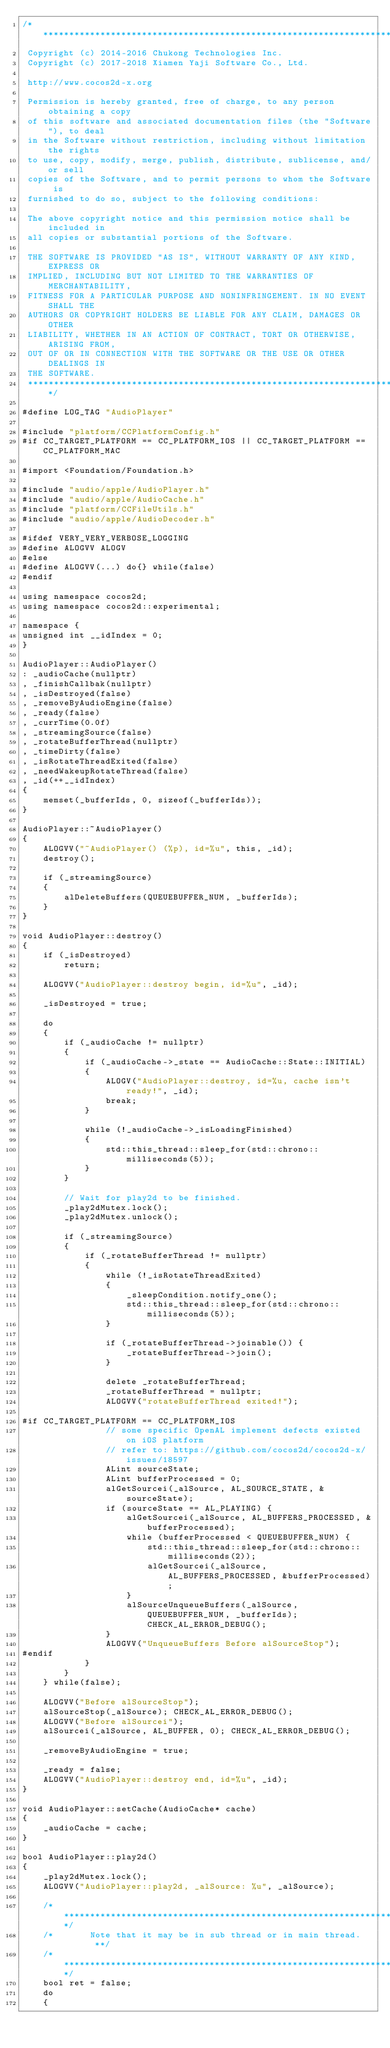<code> <loc_0><loc_0><loc_500><loc_500><_ObjectiveC_>/****************************************************************************
 Copyright (c) 2014-2016 Chukong Technologies Inc.
 Copyright (c) 2017-2018 Xiamen Yaji Software Co., Ltd.

 http://www.cocos2d-x.org

 Permission is hereby granted, free of charge, to any person obtaining a copy
 of this software and associated documentation files (the "Software"), to deal
 in the Software without restriction, including without limitation the rights
 to use, copy, modify, merge, publish, distribute, sublicense, and/or sell
 copies of the Software, and to permit persons to whom the Software is
 furnished to do so, subject to the following conditions:

 The above copyright notice and this permission notice shall be included in
 all copies or substantial portions of the Software.

 THE SOFTWARE IS PROVIDED "AS IS", WITHOUT WARRANTY OF ANY KIND, EXPRESS OR
 IMPLIED, INCLUDING BUT NOT LIMITED TO THE WARRANTIES OF MERCHANTABILITY,
 FITNESS FOR A PARTICULAR PURPOSE AND NONINFRINGEMENT. IN NO EVENT SHALL THE
 AUTHORS OR COPYRIGHT HOLDERS BE LIABLE FOR ANY CLAIM, DAMAGES OR OTHER
 LIABILITY, WHETHER IN AN ACTION OF CONTRACT, TORT OR OTHERWISE, ARISING FROM,
 OUT OF OR IN CONNECTION WITH THE SOFTWARE OR THE USE OR OTHER DEALINGS IN
 THE SOFTWARE.
 ****************************************************************************/

#define LOG_TAG "AudioPlayer"

#include "platform/CCPlatformConfig.h"
#if CC_TARGET_PLATFORM == CC_PLATFORM_IOS || CC_TARGET_PLATFORM == CC_PLATFORM_MAC

#import <Foundation/Foundation.h>

#include "audio/apple/AudioPlayer.h"
#include "audio/apple/AudioCache.h"
#include "platform/CCFileUtils.h"
#include "audio/apple/AudioDecoder.h"

#ifdef VERY_VERY_VERBOSE_LOGGING
#define ALOGVV ALOGV
#else
#define ALOGVV(...) do{} while(false)
#endif

using namespace cocos2d;
using namespace cocos2d::experimental;

namespace {
unsigned int __idIndex = 0;
}

AudioPlayer::AudioPlayer()
: _audioCache(nullptr)
, _finishCallbak(nullptr)
, _isDestroyed(false)
, _removeByAudioEngine(false)
, _ready(false)
, _currTime(0.0f)
, _streamingSource(false)
, _rotateBufferThread(nullptr)
, _timeDirty(false)
, _isRotateThreadExited(false)
, _needWakeupRotateThread(false)
, _id(++__idIndex)
{
    memset(_bufferIds, 0, sizeof(_bufferIds));
}

AudioPlayer::~AudioPlayer()
{
    ALOGVV("~AudioPlayer() (%p), id=%u", this, _id);
    destroy();

    if (_streamingSource)
    {
        alDeleteBuffers(QUEUEBUFFER_NUM, _bufferIds);
    }
}

void AudioPlayer::destroy()
{
    if (_isDestroyed)
        return;

    ALOGVV("AudioPlayer::destroy begin, id=%u", _id);

    _isDestroyed = true;

    do
    {
        if (_audioCache != nullptr)
        {
            if (_audioCache->_state == AudioCache::State::INITIAL)
            {
                ALOGV("AudioPlayer::destroy, id=%u, cache isn't ready!", _id);
                break;
            }

            while (!_audioCache->_isLoadingFinished)
            {
                std::this_thread::sleep_for(std::chrono::milliseconds(5));
            }
        }

        // Wait for play2d to be finished.
        _play2dMutex.lock();
        _play2dMutex.unlock();

        if (_streamingSource)
        {
            if (_rotateBufferThread != nullptr)
            {
                while (!_isRotateThreadExited)
                {
                    _sleepCondition.notify_one();
                    std::this_thread::sleep_for(std::chrono::milliseconds(5));
                }

                if (_rotateBufferThread->joinable()) {
                    _rotateBufferThread->join();
                }

                delete _rotateBufferThread;
                _rotateBufferThread = nullptr;
                ALOGVV("rotateBufferThread exited!");

#if CC_TARGET_PLATFORM == CC_PLATFORM_IOS
                // some specific OpenAL implement defects existed on iOS platform
                // refer to: https://github.com/cocos2d/cocos2d-x/issues/18597
                ALint sourceState;
                ALint bufferProcessed = 0;
                alGetSourcei(_alSource, AL_SOURCE_STATE, &sourceState);
                if (sourceState == AL_PLAYING) {
                    alGetSourcei(_alSource, AL_BUFFERS_PROCESSED, &bufferProcessed);
                    while (bufferProcessed < QUEUEBUFFER_NUM) {
                        std::this_thread::sleep_for(std::chrono::milliseconds(2));
                        alGetSourcei(_alSource, AL_BUFFERS_PROCESSED, &bufferProcessed);
                    }
                    alSourceUnqueueBuffers(_alSource, QUEUEBUFFER_NUM, _bufferIds); CHECK_AL_ERROR_DEBUG();
                }
                ALOGVV("UnqueueBuffers Before alSourceStop");
#endif
            }
        }
    } while(false);

    ALOGVV("Before alSourceStop");
    alSourceStop(_alSource); CHECK_AL_ERROR_DEBUG();
    ALOGVV("Before alSourcei");
    alSourcei(_alSource, AL_BUFFER, 0); CHECK_AL_ERROR_DEBUG();

    _removeByAudioEngine = true;

    _ready = false;
    ALOGVV("AudioPlayer::destroy end, id=%u", _id);
}

void AudioPlayer::setCache(AudioCache* cache)
{
    _audioCache = cache;
}

bool AudioPlayer::play2d()
{
    _play2dMutex.lock();
    ALOGVV("AudioPlayer::play2d, _alSource: %u", _alSource);

    /*********************************************************************/
    /*       Note that it may be in sub thread or in main thread.       **/
    /*********************************************************************/
    bool ret = false;
    do
    {</code> 